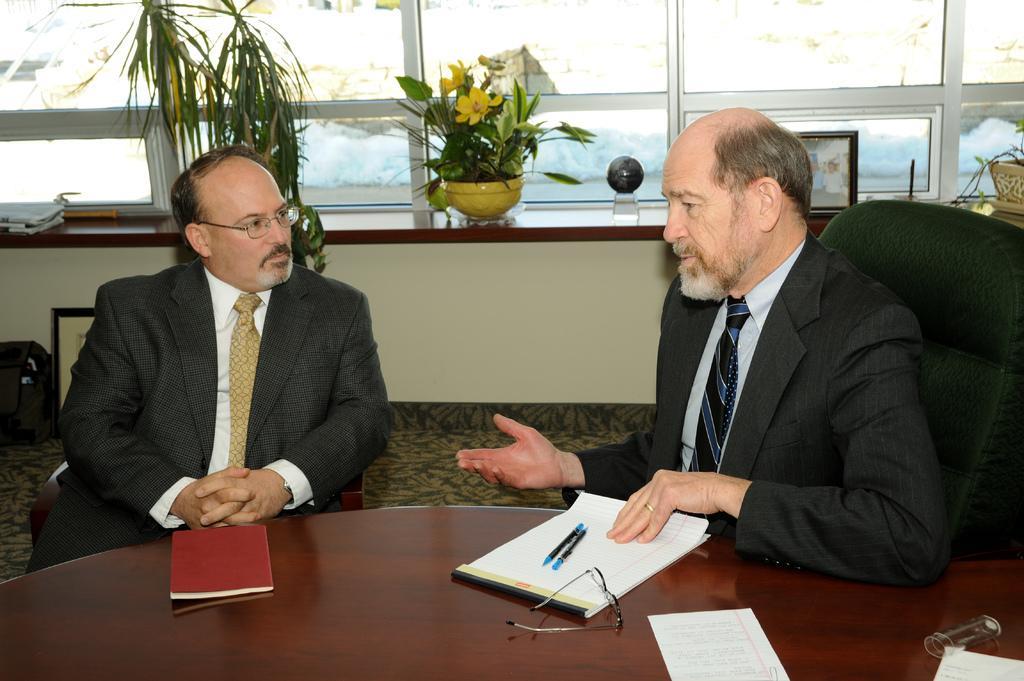Can you describe this image briefly? In the image there are two men in black suits sitting in front of table with books,pens,paper on it and behind them there are plants and flower vase on the wall in front of the glass window. 